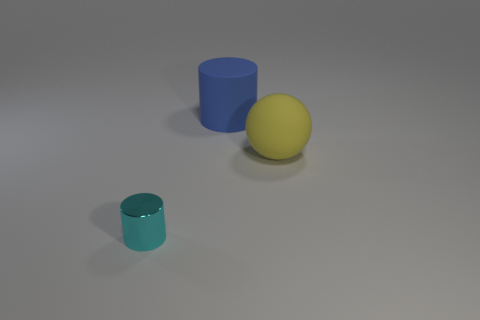Is there anything else that has the same material as the tiny cylinder?
Make the answer very short. No. Do the large thing on the left side of the yellow object and the tiny cyan object have the same material?
Offer a terse response. No. What number of objects are small green rubber objects or large yellow spheres?
Offer a very short reply. 1. What number of other objects are the same shape as the small cyan object?
Make the answer very short. 1. Are there any yellow matte spheres?
Your response must be concise. Yes. What number of things are either small green rubber cubes or cylinders behind the tiny thing?
Your response must be concise. 1. Is the size of the cylinder that is behind the cyan object the same as the cyan shiny object?
Your response must be concise. No. How many other objects are there of the same size as the blue cylinder?
Your response must be concise. 1. The matte sphere has what color?
Your response must be concise. Yellow. What is the object to the left of the large matte cylinder made of?
Offer a very short reply. Metal. 